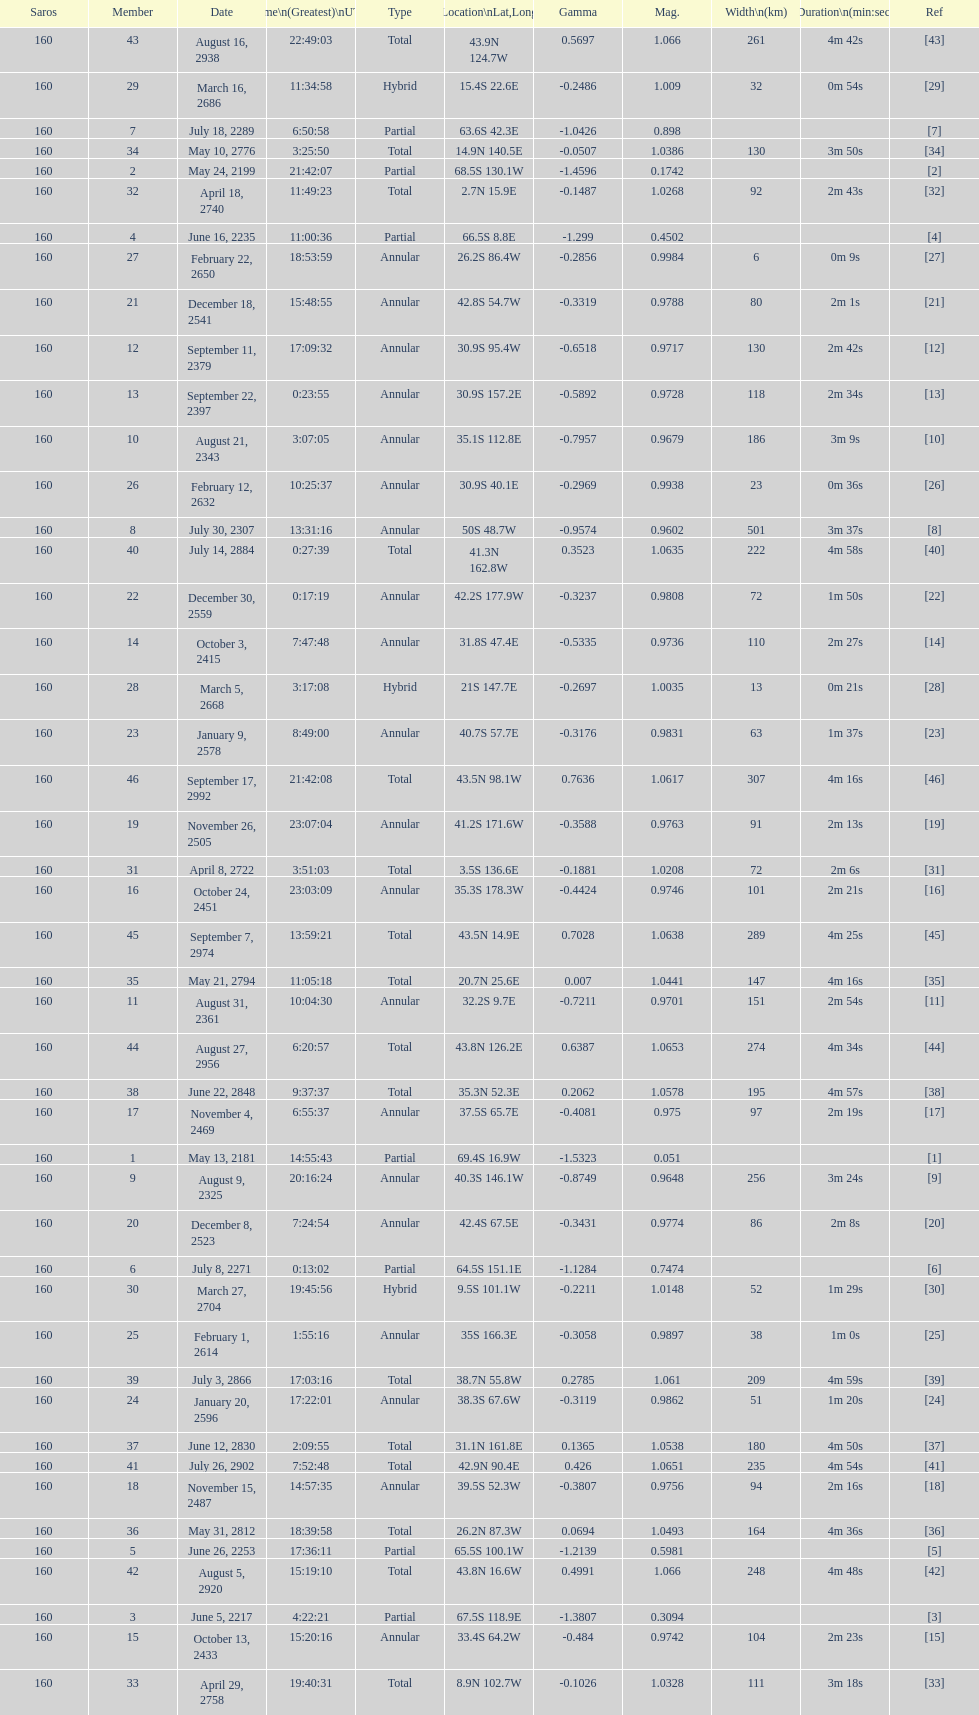How many partial members will occur before the first annular? 7. 